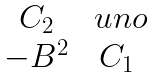Convert formula to latex. <formula><loc_0><loc_0><loc_500><loc_500>\begin{matrix} C _ { 2 } & \ u n o \\ - B ^ { 2 } & C _ { 1 } \end{matrix}</formula> 